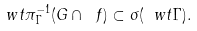Convert formula to latex. <formula><loc_0><loc_0><loc_500><loc_500>\ w t { \pi } _ { \Gamma } ^ { - 1 } ( G \cap \ f ) \subset \sigma ( \ w t { \Gamma } ) .</formula> 